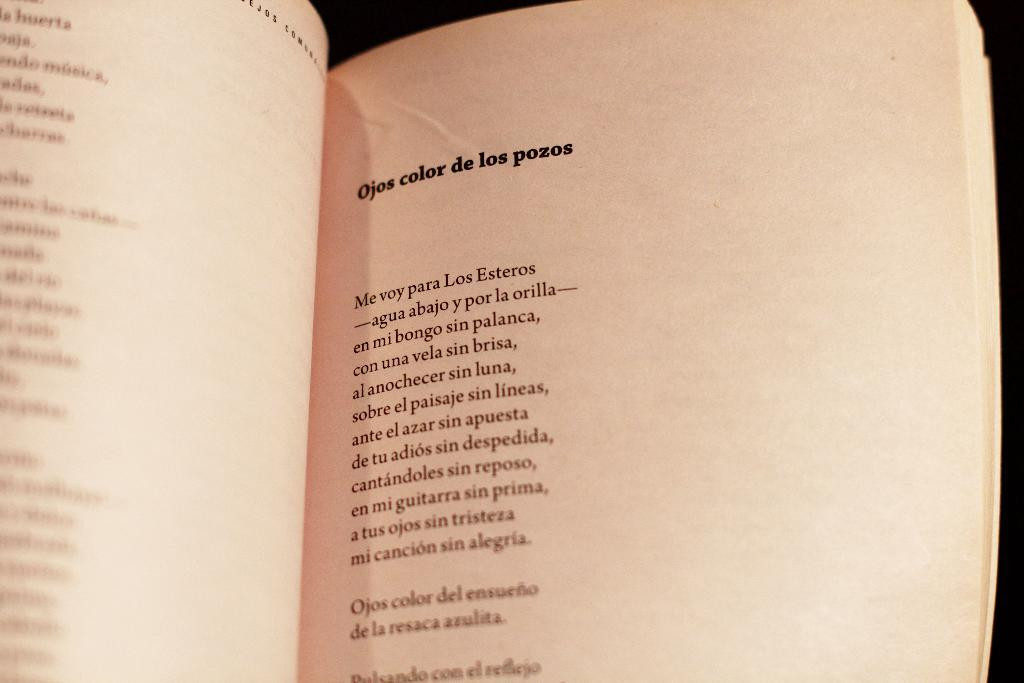<image>
Share a concise interpretation of the image provided. A book of poetry is open to a poem called Ojos Color de los pozos. 